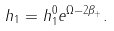Convert formula to latex. <formula><loc_0><loc_0><loc_500><loc_500>h _ { 1 } = h _ { 1 } ^ { 0 } e ^ { \Omega - 2 \beta _ { + } } .</formula> 